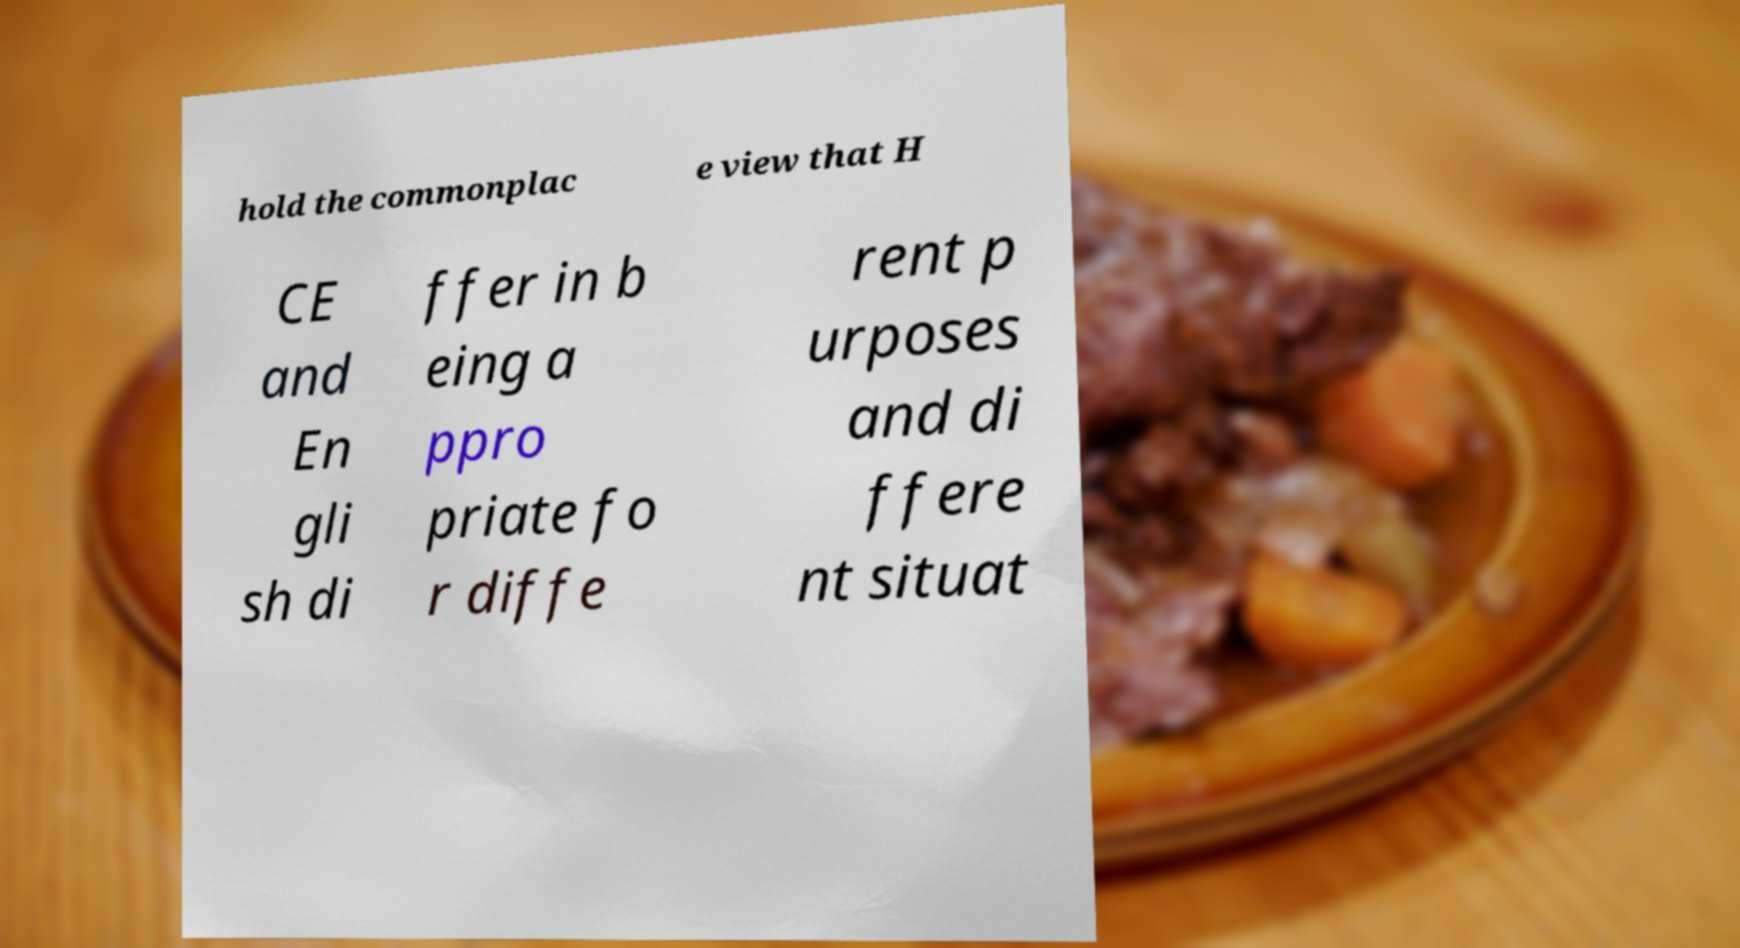I need the written content from this picture converted into text. Can you do that? hold the commonplac e view that H CE and En gli sh di ffer in b eing a ppro priate fo r diffe rent p urposes and di ffere nt situat 